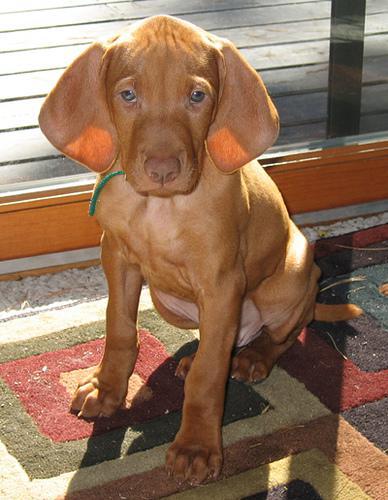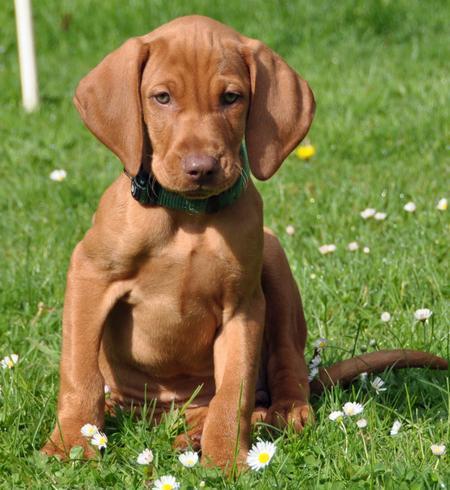The first image is the image on the left, the second image is the image on the right. Analyze the images presented: Is the assertion "Each image shows a single red-orange dog sitting upright, and at least one of the dogs depicted is wearing a collar." valid? Answer yes or no. Yes. The first image is the image on the left, the second image is the image on the right. Evaluate the accuracy of this statement regarding the images: "All the dogs are sitting.". Is it true? Answer yes or no. Yes. 